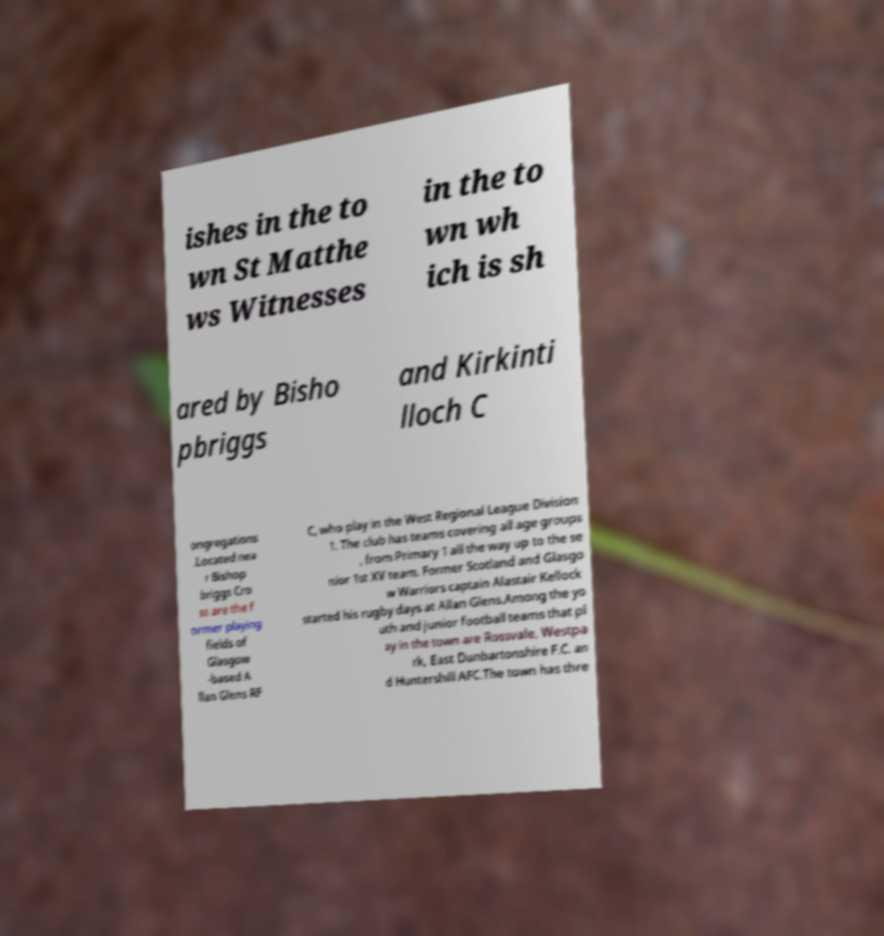Can you read and provide the text displayed in the image?This photo seems to have some interesting text. Can you extract and type it out for me? ishes in the to wn St Matthe ws Witnesses in the to wn wh ich is sh ared by Bisho pbriggs and Kirkinti lloch C ongregations .Located nea r Bishop briggs Cro ss are the f ormer playing fields of Glasgow -based A llan Glens RF C, who play in the West Regional League Division 1. The club has teams covering all age groups , from Primary 1 all the way up to the se nior 1st XV team. Former Scotland and Glasgo w Warriors captain Alastair Kellock started his rugby days at Allan Glens.Among the yo uth and junior football teams that pl ay in the town are Rossvale, Westpa rk, East Dunbartonshire F.C. an d Huntershill AFC.The town has thre 